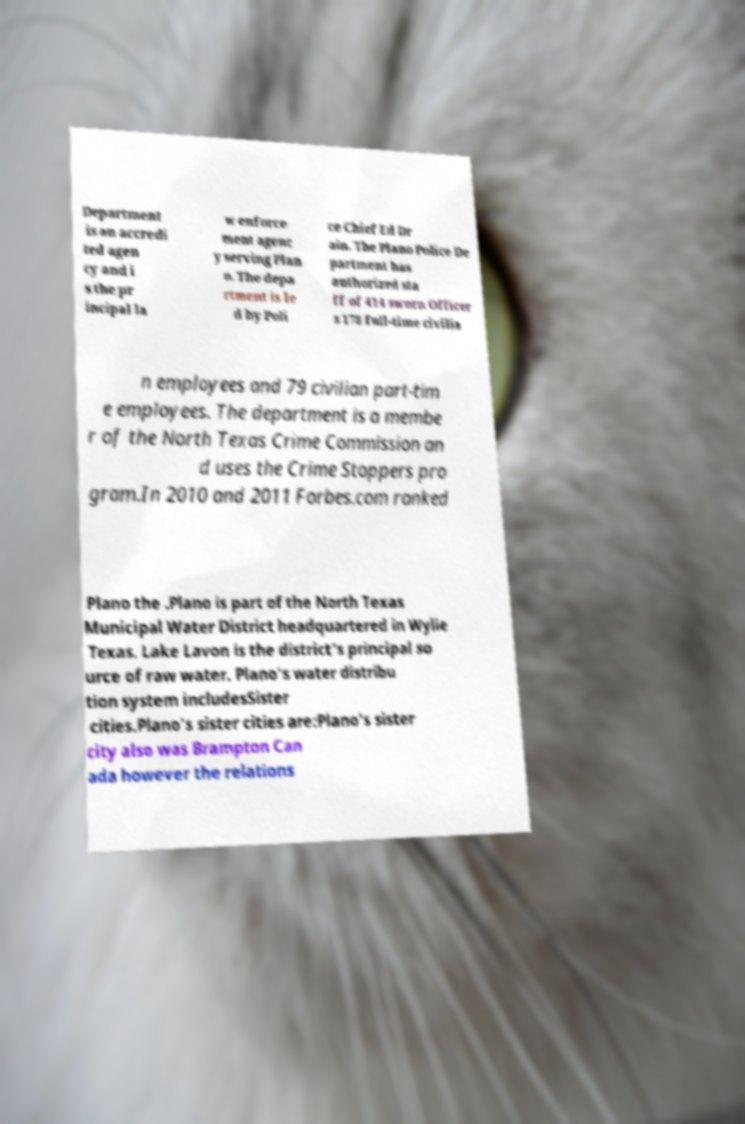I need the written content from this picture converted into text. Can you do that? Department is an accredi ted agen cy and i s the pr incipal la w enforce ment agenc y serving Plan o. The depa rtment is le d by Poli ce Chief Ed Dr ain. The Plano Police De partment has authorized sta ff of 414 sworn Officer s 178 full-time civilia n employees and 79 civilian part-tim e employees. The department is a membe r of the North Texas Crime Commission an d uses the Crime Stoppers pro gram.In 2010 and 2011 Forbes.com ranked Plano the .Plano is part of the North Texas Municipal Water District headquartered in Wylie Texas. Lake Lavon is the district's principal so urce of raw water. Plano's water distribu tion system includesSister cities.Plano's sister cities are:Plano's sister city also was Brampton Can ada however the relations 